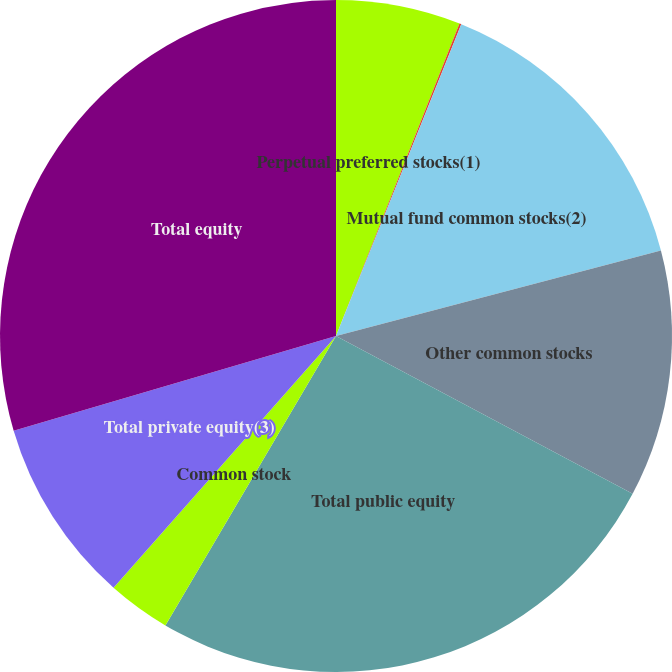Convert chart. <chart><loc_0><loc_0><loc_500><loc_500><pie_chart><fcel>Perpetual preferred stocks(1)<fcel>Non-redeemable preferred<fcel>Mutual fund common stocks(2)<fcel>Other common stocks<fcel>Total public equity<fcel>Common stock<fcel>Total private equity(3)<fcel>Total equity<nl><fcel>5.99%<fcel>0.09%<fcel>14.82%<fcel>11.88%<fcel>25.69%<fcel>3.04%<fcel>8.93%<fcel>29.55%<nl></chart> 